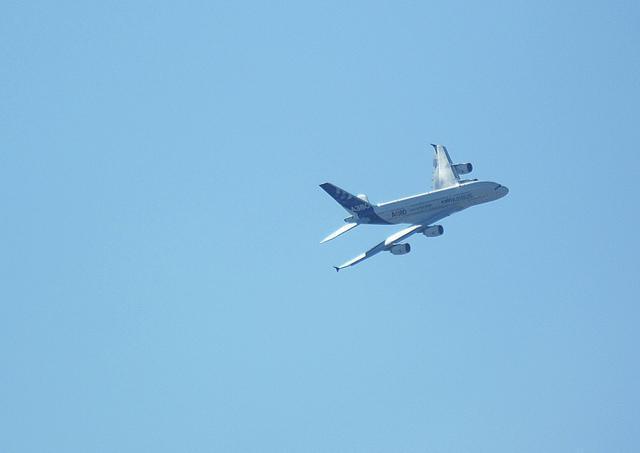How many zebras are here?
Give a very brief answer. 0. 